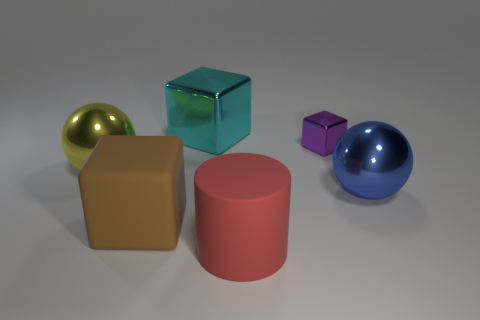What kind of lighting is used in the scene to create the shadows? The shadows in the scene are soft and diffused, indicating the use of ambient lighting, possibly combined with a soft directional light source to create the gentle contrast and soft-edged shadows. 